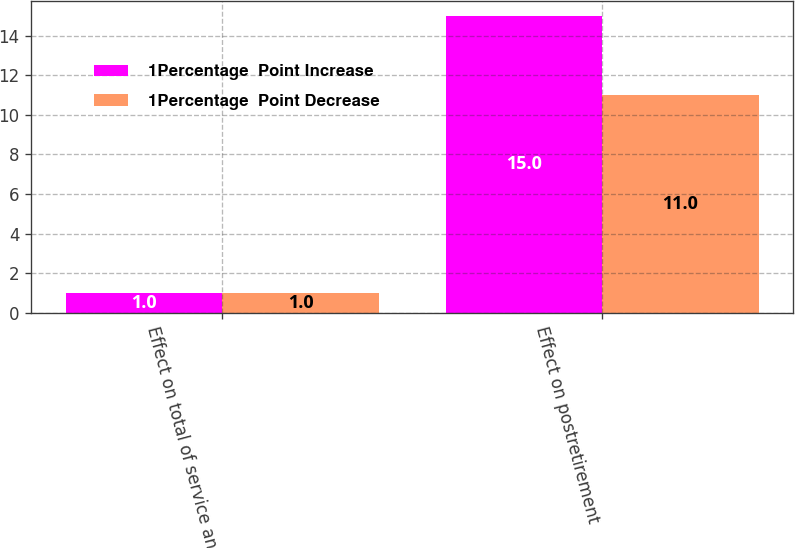<chart> <loc_0><loc_0><loc_500><loc_500><stacked_bar_chart><ecel><fcel>Effect on total of service and<fcel>Effect on postretirement<nl><fcel>1Percentage  Point Increase<fcel>1<fcel>15<nl><fcel>1Percentage  Point Decrease<fcel>1<fcel>11<nl></chart> 